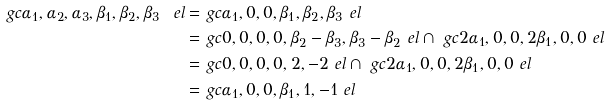Convert formula to latex. <formula><loc_0><loc_0><loc_500><loc_500>\ g c { \alpha _ { 1 } , \alpha _ { 2 } , \alpha _ { 3 } , \beta _ { 1 } , \beta _ { 2 } , \beta _ { 3 } } \ e l = & \ g c { \alpha _ { 1 } , 0 , 0 , \beta _ { 1 } , \beta _ { 2 } , \beta _ { 3 } } \ e l \\ = & \ g c { 0 , 0 , 0 , 0 , \beta _ { 2 } - \beta _ { 3 } , \beta _ { 3 } - \beta _ { 2 } } \ e l \cap \ g c { 2 \alpha _ { 1 } , 0 , 0 , 2 \beta _ { 1 } , 0 , 0 } \ e l \\ = & \ g c { 0 , 0 , 0 , 0 , 2 , - 2 } \ e l \cap \ g c { 2 \alpha _ { 1 } , 0 , 0 , 2 \beta _ { 1 } , 0 , 0 } \ e l \\ = & \ g c { \alpha _ { 1 } , 0 , 0 , \beta _ { 1 } , 1 , - 1 } \ e l</formula> 